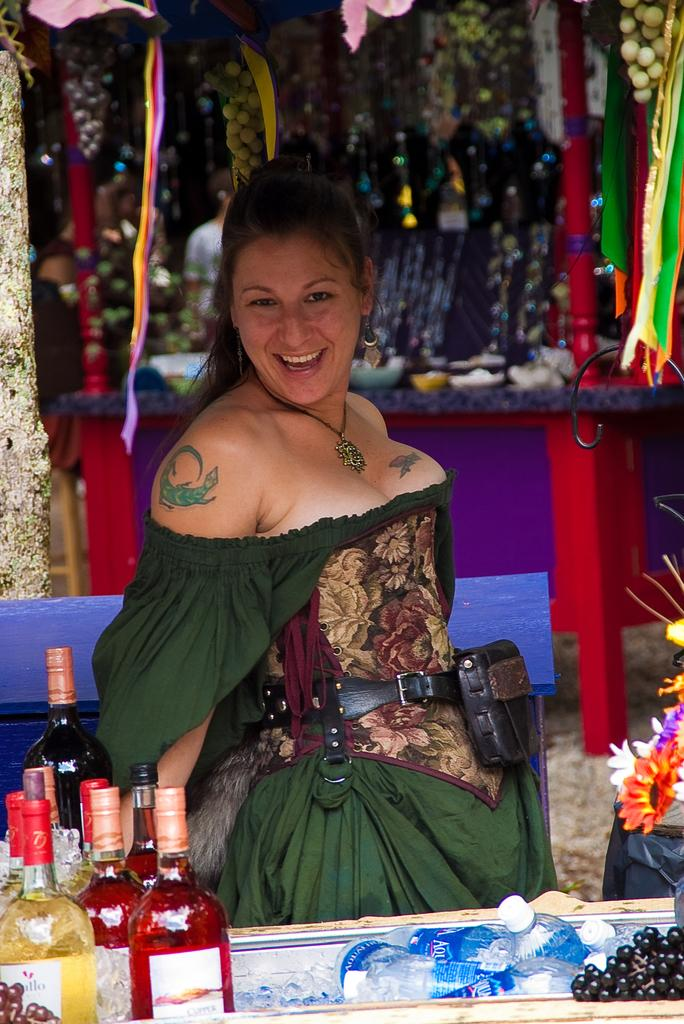What color is the dress the woman is wearing in the image? The woman is wearing a green dress in the image. What is the woman's facial expression in the image? The woman is smiling in the image. Can you describe any body art visible on the woman? There is a tattoo on the woman's hand in the image. What objects can be seen on the table in the image? There are bottles, flowers, and fruits on the table in the image. Are there any other items on the table that are not specified? Yes, there are unspecified things on the table in the image. What type of marble is visible in the image? There is no marble present in the image. What section of the library is the woman in, as seen in the image? The image does not depict a library, so it is not possible to determine the woman's location within a library. 